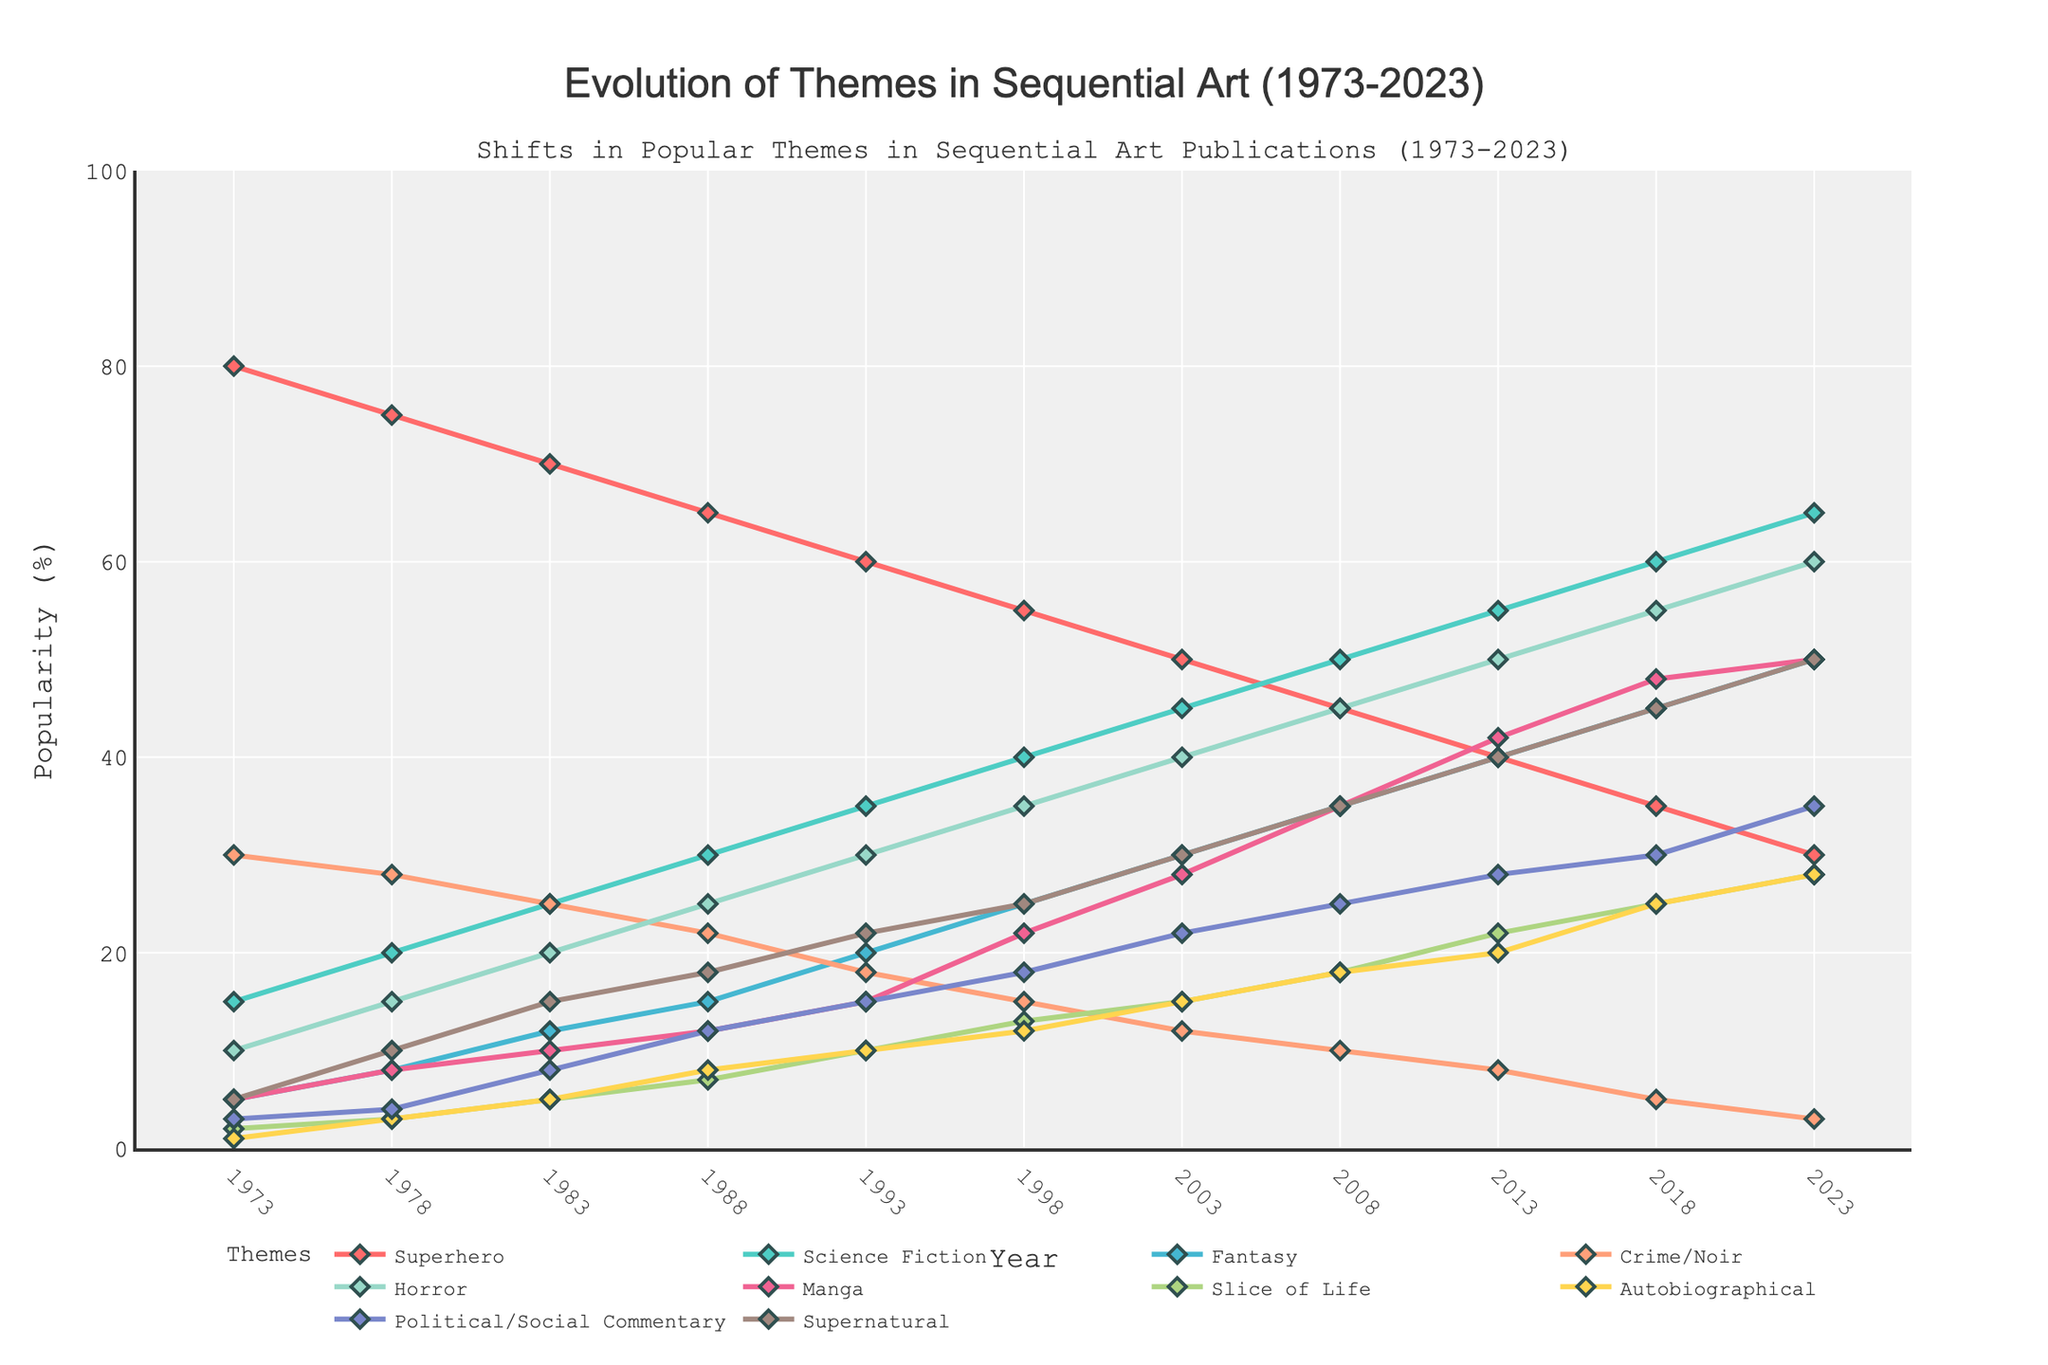What is the title of the figure? The title is located at the top of the figure and usually summarizes the main idea of the plot. Here, it reads "Evolution of Themes in Sequential Art (1973-2023)" which indicates the time span and the focus of the data.
Answer: Evolution of Themes in Sequential Art (1973-2023) What are the themes being plotted in this figure? The themes being plotted in the figure are listed in the legend on the right side of the plot. They include 'Superhero', 'Science Fiction', 'Fantasy', 'Crime/Noir', 'Horror', 'Manga', 'Slice of Life', 'Autobiographical', 'Political/Social Commentary', and 'Supernatural'.
Answer: Superhero, Science Fiction, Fantasy, Crime/Noir, Horror, Manga, Slice of Life, Autobiographical, Political/Social Commentary, Supernatural Which theme showed the most significant increase in popularity from 1973 to 2023? By comparing the position of each theme's line at the start (1973) and the end (2023) of the plot, 'Supernatural' shows the most significant increase; it starts at 5% in 1973 and rises to 50% in 2023, an increase of 45 percentage points.
Answer: Supernatural What year saw 'Horror' surpass 'Superhero' in popularity? By tracing the lines for 'Horror' and 'Superhero', we see that 'Horror' surpasses 'Superhero' between 2003 and 2008. This can be pinpointed more accurately by checking the point where the 'Horror' line goes above the 'Superhero' line, which occurs at 2008.
Answer: 2008 How has the popularity of 'Science Fiction' changed over the 50 years? The line for 'Science Fiction' is tracked to observe changes from 1973 to 2023. It starts at 15%, and consistently increases every five-year interval up to 65%, showing a continuous upward trend in popularity.
Answer: Increased What two themes have the most similar popularity in 2023? By comparing the values at the 2023 mark for each theme, 'Manga' and 'Fantasy' are closest in percentage, both around 50%.
Answer: Fantasy, Manga Which theme had a burst in popularity around 1998 and has maintained a high level since? The line representing 'Horror' shows a notable increase around the year 1998, jumping from 30% in 1993 to 35% in 1998, and continues to rise steadily, reaching 60% in 2023.
Answer: Horror In what year did 'Autobiographical' themes reach a popularity of 15%? By following the 'Autobiographical' line, it intersects the 15% mark at the year 2003.
Answer: 2003 By how much did the popularity of 'Slice of Life' themes grow from 1973 to 2023? In 1973, 'Slice of Life' was at 2%, and by 2023, it increased to 28%. The growth can be calculated as 28% - 2% = 26%.
Answer: 26% What theme saw a decline in popularity between 1973 and 2023, and by how much? 'Superhero' themes started at 80% in 1973 and declined to 30% in 2023. The decrease is calculated as 80% - 30% = 50%.
Answer: Superhero, 50% 